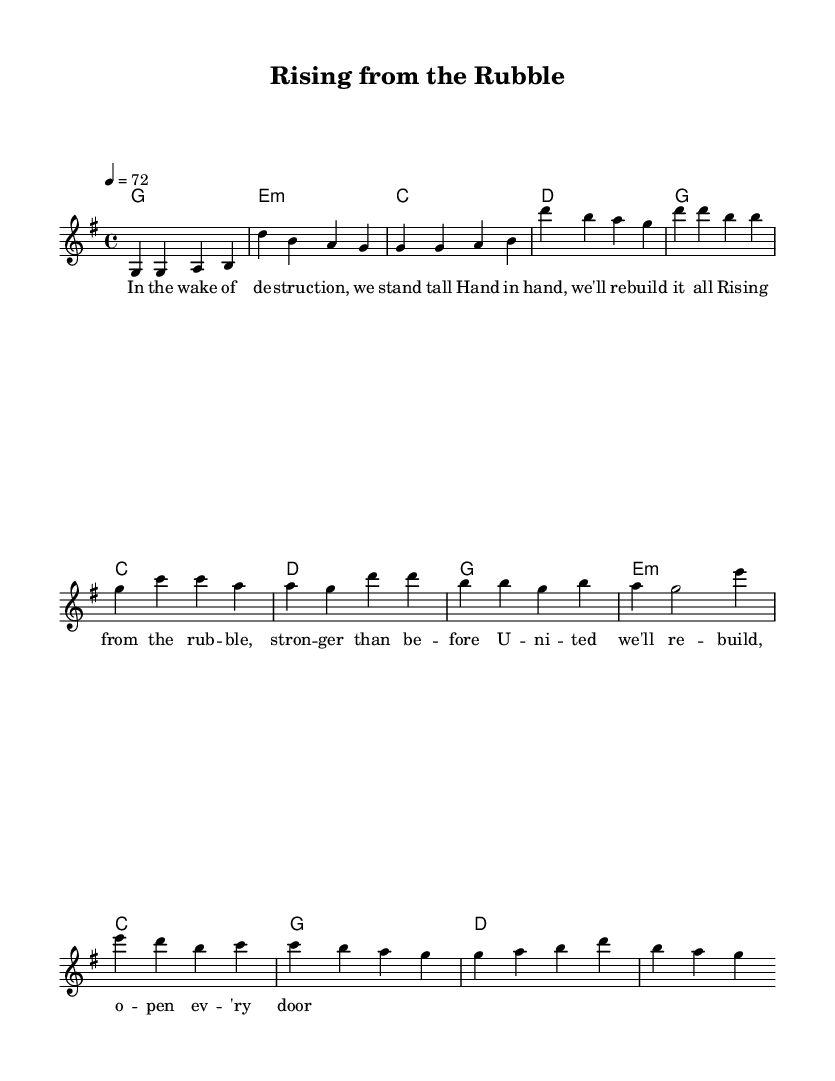What is the key signature of this music? The key signature is G major, which has one sharp (F#).
Answer: G major What is the time signature of this piece? The time signature is 4/4, meaning there are four beats in each measure and the quarter note gets one beat.
Answer: 4/4 What is the tempo marking for this music? The tempo marking indicates a speed of 72 beats per minute, specifying how fast the piece should be played.
Answer: 72 How many measures are in the verse section? The verse section consists of 4 measures as evidenced by the repeated patterns of notes and the way they are structured.
Answer: 4 How many chords are used in the chorus? The chorus uses three different chords: G, C, and D which are evident in the chord progression laid out.
Answer: 3 What is the overall theme of the lyrics in the song? The lyrics focus on themes of resilience and unity in the aftermath of destruction, highlighting the importance of coming together to rebuild.
Answer: Rebuilding community Which section of the music contains the bridge? The bridge section is situated between the chorus and the following verse, often serving as a contrasting segment within the song structure.
Answer: The bridge 